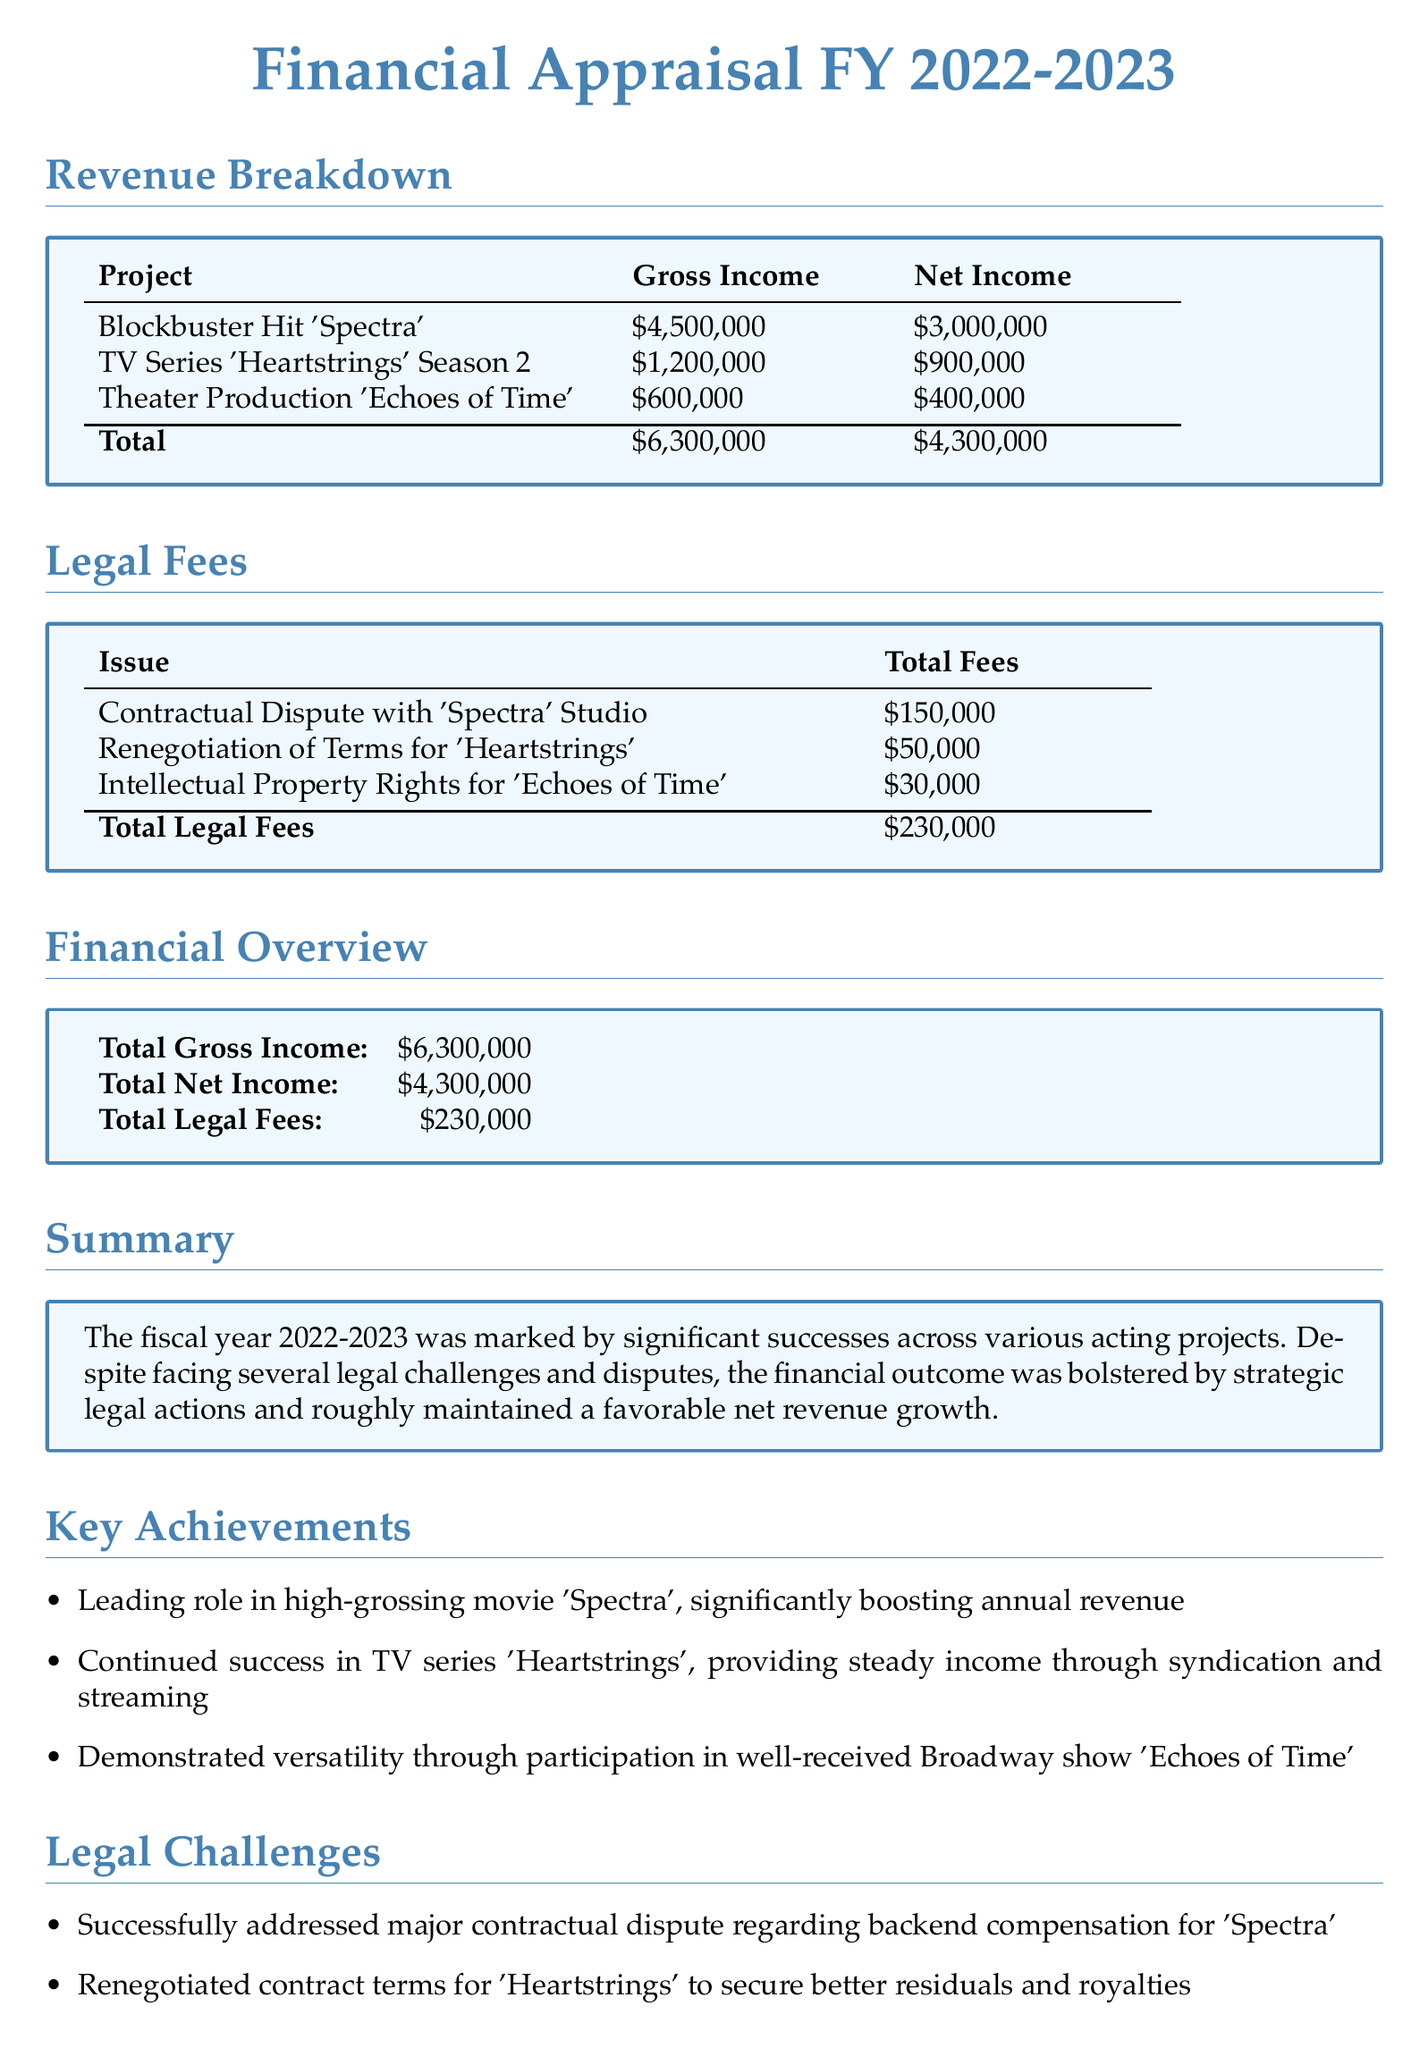What is the total gross income? The total gross income is listed in the financial overview section as \$6,300,000.
Answer: \$6,300,000 How much did you earn from 'Spectra'? The gross income from the project 'Spectra' is stated as \$4,500,000.
Answer: \$4,500,000 What are the total legal fees? The total legal fees provided in the document sum up to \$230,000.
Answer: \$230,000 Which project had the highest net income? The project with the highest net income is 'Spectra' with \$3,000,000.
Answer: 'Spectra' How much was spent on the 'Heartstrings' contract renegotiation? The document specifies that the total fees for renegotiating 'Heartstrings' were \$50,000.
Answer: \$50,000 What is the net income from 'Echoes of Time'? The net income from 'Echoes of Time' is indicated as \$400,000 in the revenue breakdown.
Answer: \$400,000 How many legal issues are listed in the document? The document mentions three legal issues related to contracts and rights.
Answer: Three What was one of the key achievements mentioned? One of the key achievements is leading a role in the high-grossing movie 'Spectra'.
Answer: Leading role in 'Spectra' What was resolved in the 'Echoes of Time' legal challenge? The legal challenge for 'Echoes of Time' involved resolving intellectual property rights.
Answer: Intellectual property rights 